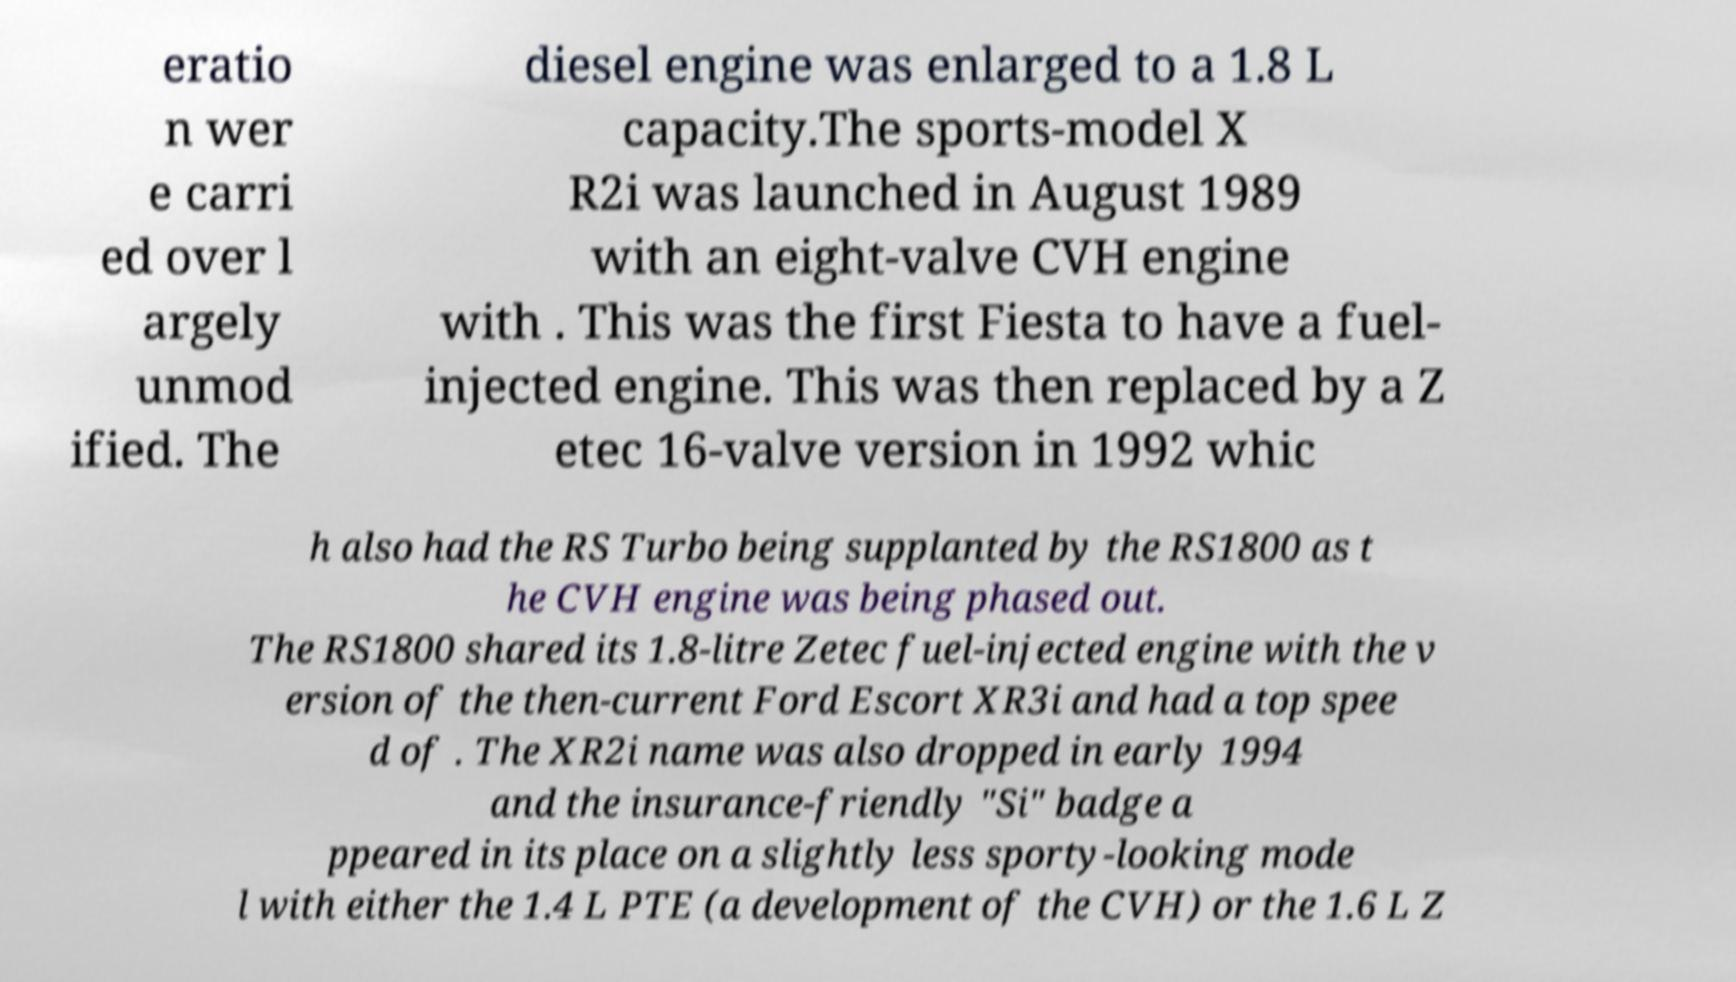Can you accurately transcribe the text from the provided image for me? eratio n wer e carri ed over l argely unmod ified. The diesel engine was enlarged to a 1.8 L capacity.The sports-model X R2i was launched in August 1989 with an eight-valve CVH engine with . This was the first Fiesta to have a fuel- injected engine. This was then replaced by a Z etec 16-valve version in 1992 whic h also had the RS Turbo being supplanted by the RS1800 as t he CVH engine was being phased out. The RS1800 shared its 1.8-litre Zetec fuel-injected engine with the v ersion of the then-current Ford Escort XR3i and had a top spee d of . The XR2i name was also dropped in early 1994 and the insurance-friendly "Si" badge a ppeared in its place on a slightly less sporty-looking mode l with either the 1.4 L PTE (a development of the CVH) or the 1.6 L Z 